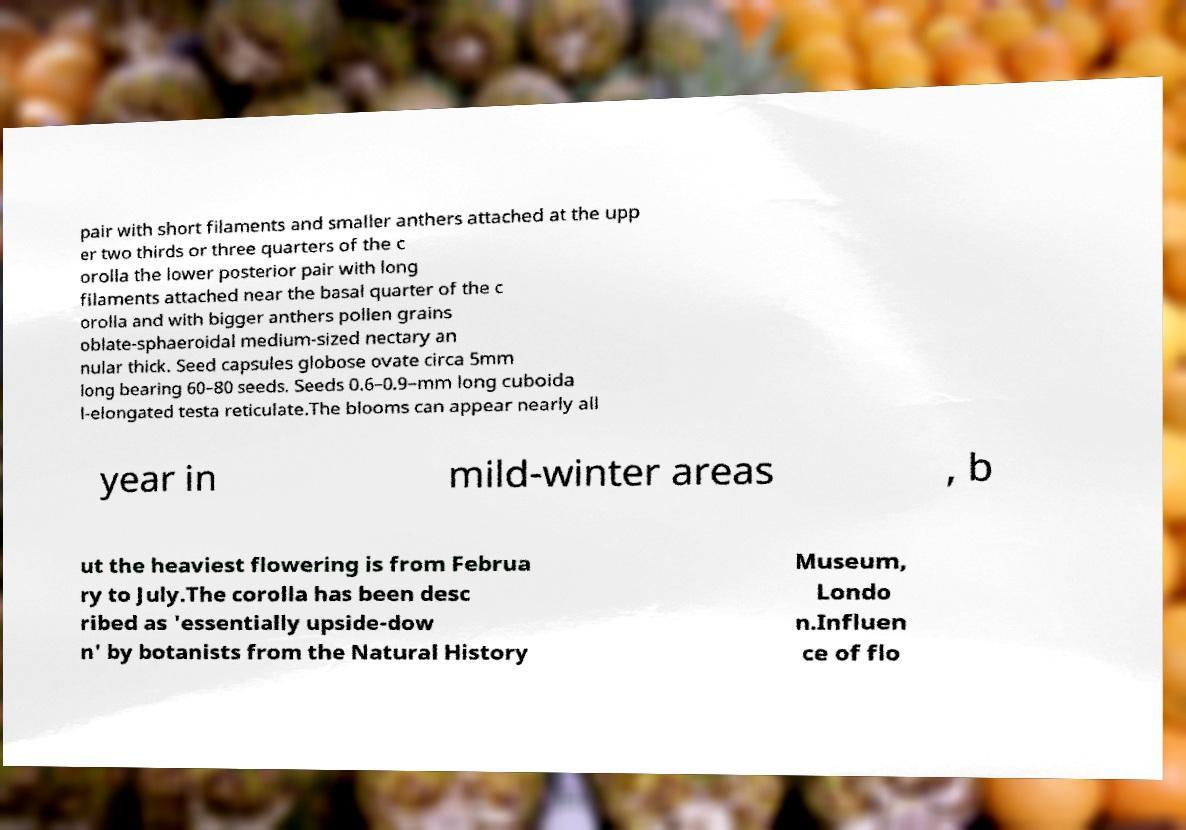What messages or text are displayed in this image? I need them in a readable, typed format. pair with short filaments and smaller anthers attached at the upp er two thirds or three quarters of the c orolla the lower posterior pair with long filaments attached near the basal quarter of the c orolla and with bigger anthers pollen grains oblate-sphaeroidal medium-sized nectary an nular thick. Seed capsules globose ovate circa 5mm long bearing 60–80 seeds. Seeds 0.6–0.9–mm long cuboida l-elongated testa reticulate.The blooms can appear nearly all year in mild-winter areas , b ut the heaviest flowering is from Februa ry to July.The corolla has been desc ribed as 'essentially upside-dow n' by botanists from the Natural History Museum, Londo n.Influen ce of flo 